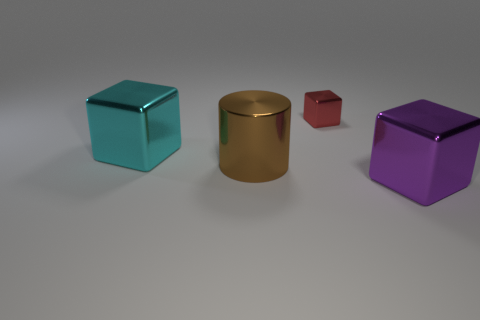What shapes are the objects in the scene, and are they positioned in a specific pattern? The objects include a cylinder and three cubes. They are arranged with ample space between them, and there doesn't appear to be a specific pattern to their positioning. Is there any significance to their arrangement? Without additional context, it's difficult to assert any intrinsic significance to their arrangement. It could be an artistic placement, or simply be random. 